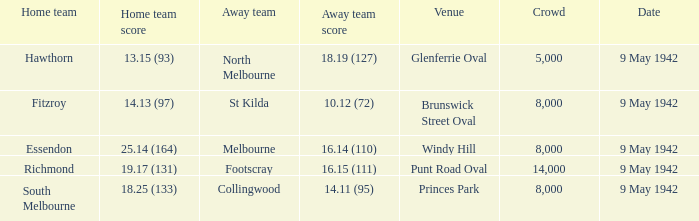How many people attended the game where Footscray was away? 14000.0. 